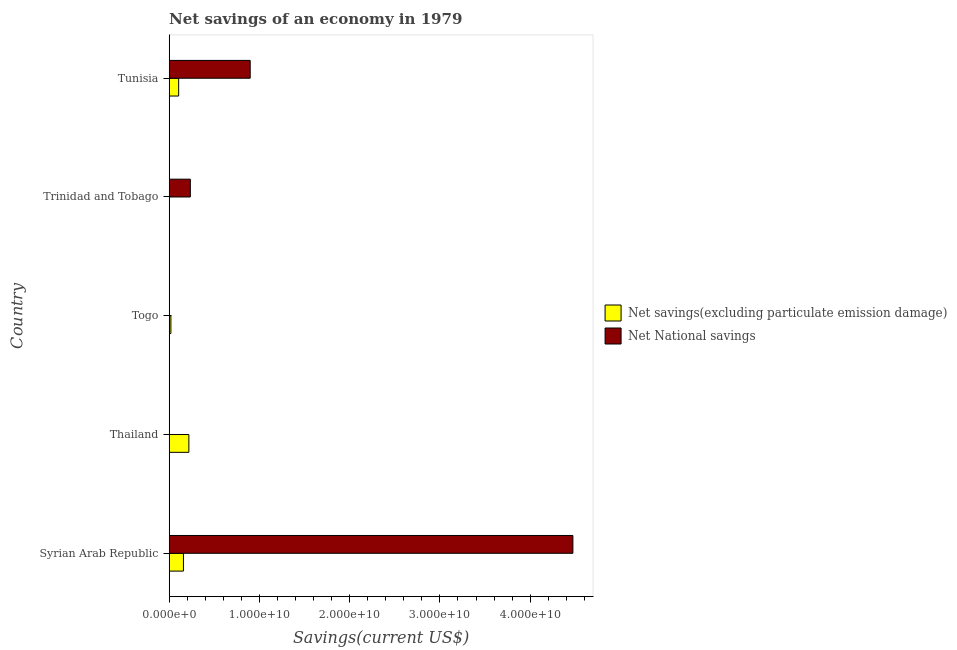Are the number of bars per tick equal to the number of legend labels?
Your answer should be very brief. No. What is the label of the 4th group of bars from the top?
Your answer should be compact. Thailand. In how many cases, is the number of bars for a given country not equal to the number of legend labels?
Your answer should be compact. 2. What is the net national savings in Trinidad and Tobago?
Give a very brief answer. 2.34e+09. Across all countries, what is the maximum net national savings?
Offer a terse response. 4.47e+1. In which country was the net national savings maximum?
Give a very brief answer. Syrian Arab Republic. What is the total net savings(excluding particulate emission damage) in the graph?
Keep it short and to the point. 4.99e+09. What is the difference between the net savings(excluding particulate emission damage) in Thailand and that in Tunisia?
Offer a terse response. 1.13e+09. What is the difference between the net savings(excluding particulate emission damage) in Togo and the net national savings in Trinidad and Tobago?
Make the answer very short. -2.15e+09. What is the average net national savings per country?
Ensure brevity in your answer.  1.12e+1. What is the difference between the net savings(excluding particulate emission damage) and net national savings in Syrian Arab Republic?
Your response must be concise. -4.32e+1. What is the ratio of the net savings(excluding particulate emission damage) in Syrian Arab Republic to that in Togo?
Your answer should be compact. 8.43. What is the difference between the highest and the second highest net national savings?
Provide a succinct answer. 3.58e+1. What is the difference between the highest and the lowest net savings(excluding particulate emission damage)?
Keep it short and to the point. 2.18e+09. Is the sum of the net national savings in Syrian Arab Republic and Tunisia greater than the maximum net savings(excluding particulate emission damage) across all countries?
Give a very brief answer. Yes. How many bars are there?
Your answer should be compact. 8. How many countries are there in the graph?
Offer a very short reply. 5. Does the graph contain grids?
Your answer should be compact. No. How are the legend labels stacked?
Provide a succinct answer. Vertical. What is the title of the graph?
Offer a terse response. Net savings of an economy in 1979. Does "Residents" appear as one of the legend labels in the graph?
Give a very brief answer. No. What is the label or title of the X-axis?
Offer a very short reply. Savings(current US$). What is the label or title of the Y-axis?
Offer a terse response. Country. What is the Savings(current US$) of Net savings(excluding particulate emission damage) in Syrian Arab Republic?
Make the answer very short. 1.58e+09. What is the Savings(current US$) of Net National savings in Syrian Arab Republic?
Your answer should be compact. 4.47e+1. What is the Savings(current US$) in Net savings(excluding particulate emission damage) in Thailand?
Make the answer very short. 2.18e+09. What is the Savings(current US$) of Net National savings in Thailand?
Give a very brief answer. 2.87e+07. What is the Savings(current US$) of Net savings(excluding particulate emission damage) in Togo?
Make the answer very short. 1.87e+08. What is the Savings(current US$) of Net savings(excluding particulate emission damage) in Trinidad and Tobago?
Provide a succinct answer. 0. What is the Savings(current US$) in Net National savings in Trinidad and Tobago?
Keep it short and to the point. 2.34e+09. What is the Savings(current US$) in Net savings(excluding particulate emission damage) in Tunisia?
Your answer should be very brief. 1.05e+09. What is the Savings(current US$) of Net National savings in Tunisia?
Your answer should be compact. 8.97e+09. Across all countries, what is the maximum Savings(current US$) in Net savings(excluding particulate emission damage)?
Keep it short and to the point. 2.18e+09. Across all countries, what is the maximum Savings(current US$) in Net National savings?
Offer a very short reply. 4.47e+1. Across all countries, what is the minimum Savings(current US$) in Net savings(excluding particulate emission damage)?
Offer a terse response. 0. What is the total Savings(current US$) in Net savings(excluding particulate emission damage) in the graph?
Your answer should be compact. 4.99e+09. What is the total Savings(current US$) in Net National savings in the graph?
Your answer should be very brief. 5.61e+1. What is the difference between the Savings(current US$) in Net savings(excluding particulate emission damage) in Syrian Arab Republic and that in Thailand?
Give a very brief answer. -6.02e+08. What is the difference between the Savings(current US$) of Net National savings in Syrian Arab Republic and that in Thailand?
Ensure brevity in your answer.  4.47e+1. What is the difference between the Savings(current US$) in Net savings(excluding particulate emission damage) in Syrian Arab Republic and that in Togo?
Give a very brief answer. 1.39e+09. What is the difference between the Savings(current US$) in Net National savings in Syrian Arab Republic and that in Trinidad and Tobago?
Make the answer very short. 4.24e+1. What is the difference between the Savings(current US$) in Net savings(excluding particulate emission damage) in Syrian Arab Republic and that in Tunisia?
Ensure brevity in your answer.  5.29e+08. What is the difference between the Savings(current US$) in Net National savings in Syrian Arab Republic and that in Tunisia?
Your answer should be very brief. 3.58e+1. What is the difference between the Savings(current US$) in Net savings(excluding particulate emission damage) in Thailand and that in Togo?
Your answer should be very brief. 1.99e+09. What is the difference between the Savings(current US$) in Net National savings in Thailand and that in Trinidad and Tobago?
Your answer should be very brief. -2.31e+09. What is the difference between the Savings(current US$) in Net savings(excluding particulate emission damage) in Thailand and that in Tunisia?
Your answer should be very brief. 1.13e+09. What is the difference between the Savings(current US$) of Net National savings in Thailand and that in Tunisia?
Provide a short and direct response. -8.95e+09. What is the difference between the Savings(current US$) of Net savings(excluding particulate emission damage) in Togo and that in Tunisia?
Offer a terse response. -8.61e+08. What is the difference between the Savings(current US$) in Net National savings in Trinidad and Tobago and that in Tunisia?
Your response must be concise. -6.63e+09. What is the difference between the Savings(current US$) in Net savings(excluding particulate emission damage) in Syrian Arab Republic and the Savings(current US$) in Net National savings in Thailand?
Keep it short and to the point. 1.55e+09. What is the difference between the Savings(current US$) of Net savings(excluding particulate emission damage) in Syrian Arab Republic and the Savings(current US$) of Net National savings in Trinidad and Tobago?
Give a very brief answer. -7.65e+08. What is the difference between the Savings(current US$) in Net savings(excluding particulate emission damage) in Syrian Arab Republic and the Savings(current US$) in Net National savings in Tunisia?
Keep it short and to the point. -7.40e+09. What is the difference between the Savings(current US$) in Net savings(excluding particulate emission damage) in Thailand and the Savings(current US$) in Net National savings in Trinidad and Tobago?
Give a very brief answer. -1.63e+08. What is the difference between the Savings(current US$) in Net savings(excluding particulate emission damage) in Thailand and the Savings(current US$) in Net National savings in Tunisia?
Provide a succinct answer. -6.80e+09. What is the difference between the Savings(current US$) in Net savings(excluding particulate emission damage) in Togo and the Savings(current US$) in Net National savings in Trinidad and Tobago?
Your answer should be compact. -2.15e+09. What is the difference between the Savings(current US$) in Net savings(excluding particulate emission damage) in Togo and the Savings(current US$) in Net National savings in Tunisia?
Your response must be concise. -8.79e+09. What is the average Savings(current US$) in Net savings(excluding particulate emission damage) per country?
Provide a short and direct response. 9.98e+08. What is the average Savings(current US$) in Net National savings per country?
Your answer should be compact. 1.12e+1. What is the difference between the Savings(current US$) in Net savings(excluding particulate emission damage) and Savings(current US$) in Net National savings in Syrian Arab Republic?
Keep it short and to the point. -4.32e+1. What is the difference between the Savings(current US$) in Net savings(excluding particulate emission damage) and Savings(current US$) in Net National savings in Thailand?
Give a very brief answer. 2.15e+09. What is the difference between the Savings(current US$) in Net savings(excluding particulate emission damage) and Savings(current US$) in Net National savings in Tunisia?
Offer a terse response. -7.93e+09. What is the ratio of the Savings(current US$) of Net savings(excluding particulate emission damage) in Syrian Arab Republic to that in Thailand?
Offer a very short reply. 0.72. What is the ratio of the Savings(current US$) of Net National savings in Syrian Arab Republic to that in Thailand?
Your answer should be compact. 1557.6. What is the ratio of the Savings(current US$) of Net savings(excluding particulate emission damage) in Syrian Arab Republic to that in Togo?
Your response must be concise. 8.43. What is the ratio of the Savings(current US$) in Net National savings in Syrian Arab Republic to that in Trinidad and Tobago?
Provide a short and direct response. 19.11. What is the ratio of the Savings(current US$) of Net savings(excluding particulate emission damage) in Syrian Arab Republic to that in Tunisia?
Give a very brief answer. 1.51. What is the ratio of the Savings(current US$) in Net National savings in Syrian Arab Republic to that in Tunisia?
Offer a very short reply. 4.98. What is the ratio of the Savings(current US$) in Net savings(excluding particulate emission damage) in Thailand to that in Togo?
Give a very brief answer. 11.65. What is the ratio of the Savings(current US$) in Net National savings in Thailand to that in Trinidad and Tobago?
Your response must be concise. 0.01. What is the ratio of the Savings(current US$) of Net savings(excluding particulate emission damage) in Thailand to that in Tunisia?
Make the answer very short. 2.08. What is the ratio of the Savings(current US$) of Net National savings in Thailand to that in Tunisia?
Keep it short and to the point. 0. What is the ratio of the Savings(current US$) of Net savings(excluding particulate emission damage) in Togo to that in Tunisia?
Offer a very short reply. 0.18. What is the ratio of the Savings(current US$) of Net National savings in Trinidad and Tobago to that in Tunisia?
Make the answer very short. 0.26. What is the difference between the highest and the second highest Savings(current US$) in Net savings(excluding particulate emission damage)?
Give a very brief answer. 6.02e+08. What is the difference between the highest and the second highest Savings(current US$) of Net National savings?
Your answer should be very brief. 3.58e+1. What is the difference between the highest and the lowest Savings(current US$) of Net savings(excluding particulate emission damage)?
Ensure brevity in your answer.  2.18e+09. What is the difference between the highest and the lowest Savings(current US$) in Net National savings?
Provide a succinct answer. 4.47e+1. 